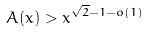Convert formula to latex. <formula><loc_0><loc_0><loc_500><loc_500>A ( x ) > x ^ { \sqrt { 2 } - 1 - o ( 1 ) }</formula> 